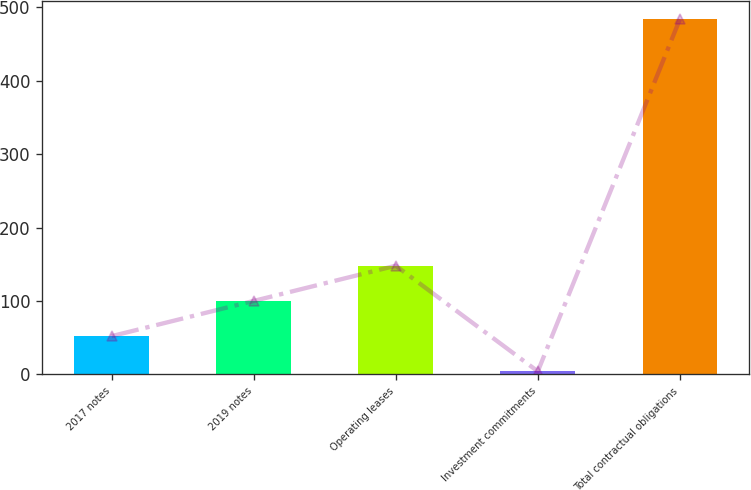<chart> <loc_0><loc_0><loc_500><loc_500><bar_chart><fcel>2017 notes<fcel>2019 notes<fcel>Operating leases<fcel>Investment commitments<fcel>Total contractual obligations<nl><fcel>52<fcel>100<fcel>148<fcel>4<fcel>484<nl></chart> 